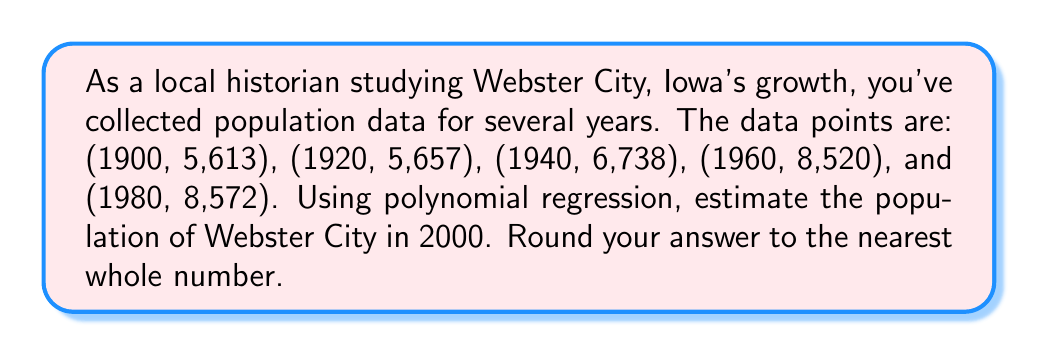Teach me how to tackle this problem. Let's approach this step-by-step using polynomial regression:

1) First, we'll use a second-degree polynomial model: $y = ax^2 + bx + c$, where $y$ is the population and $x$ is the number of years since 1900.

2) We need to set up a system of equations using the given data points:
   For 1900 (x = 0): $5613 = c$
   For 1920 (x = 20): $5657 = 400a + 20b + c$
   For 1940 (x = 40): $6738 = 1600a + 40b + c$
   For 1960 (x = 60): $8520 = 3600a + 60b + c$
   For 1980 (x = 80): $8572 = 6400a + 80b + c$

3) Using a calculator or computer algebra system to solve this system of equations, we get:
   $a \approx -0.0928125$
   $b \approx 8.74375$
   $c = 5613$

4) Our polynomial regression equation is:
   $y = -0.0928125x^2 + 8.74375x + 5613$

5) To estimate the population in 2000, we need to calculate y when x = 100:
   $y = -0.0928125(100)^2 + 8.74375(100) + 5613$
   $= -928.125 + 874.375 + 5613$
   $= 5559.25$

6) Rounding to the nearest whole number, we get 5,559.
Answer: 5,559 